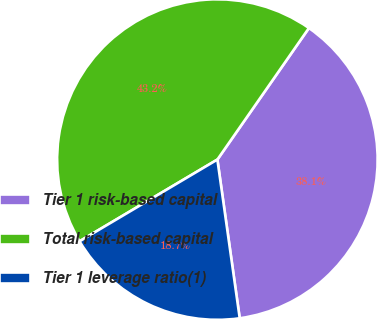<chart> <loc_0><loc_0><loc_500><loc_500><pie_chart><fcel>Tier 1 risk-based capital<fcel>Total risk-based capital<fcel>Tier 1 leverage ratio(1)<nl><fcel>38.1%<fcel>43.2%<fcel>18.71%<nl></chart> 